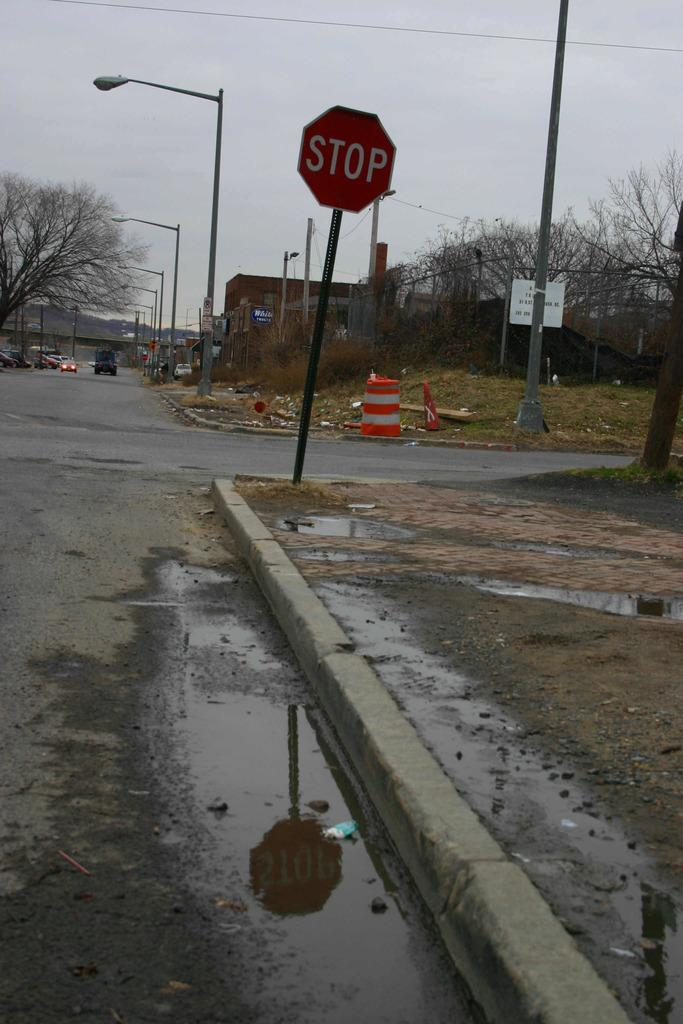<image>
Present a compact description of the photo's key features. A muddy and wet street near a STOP sign. 